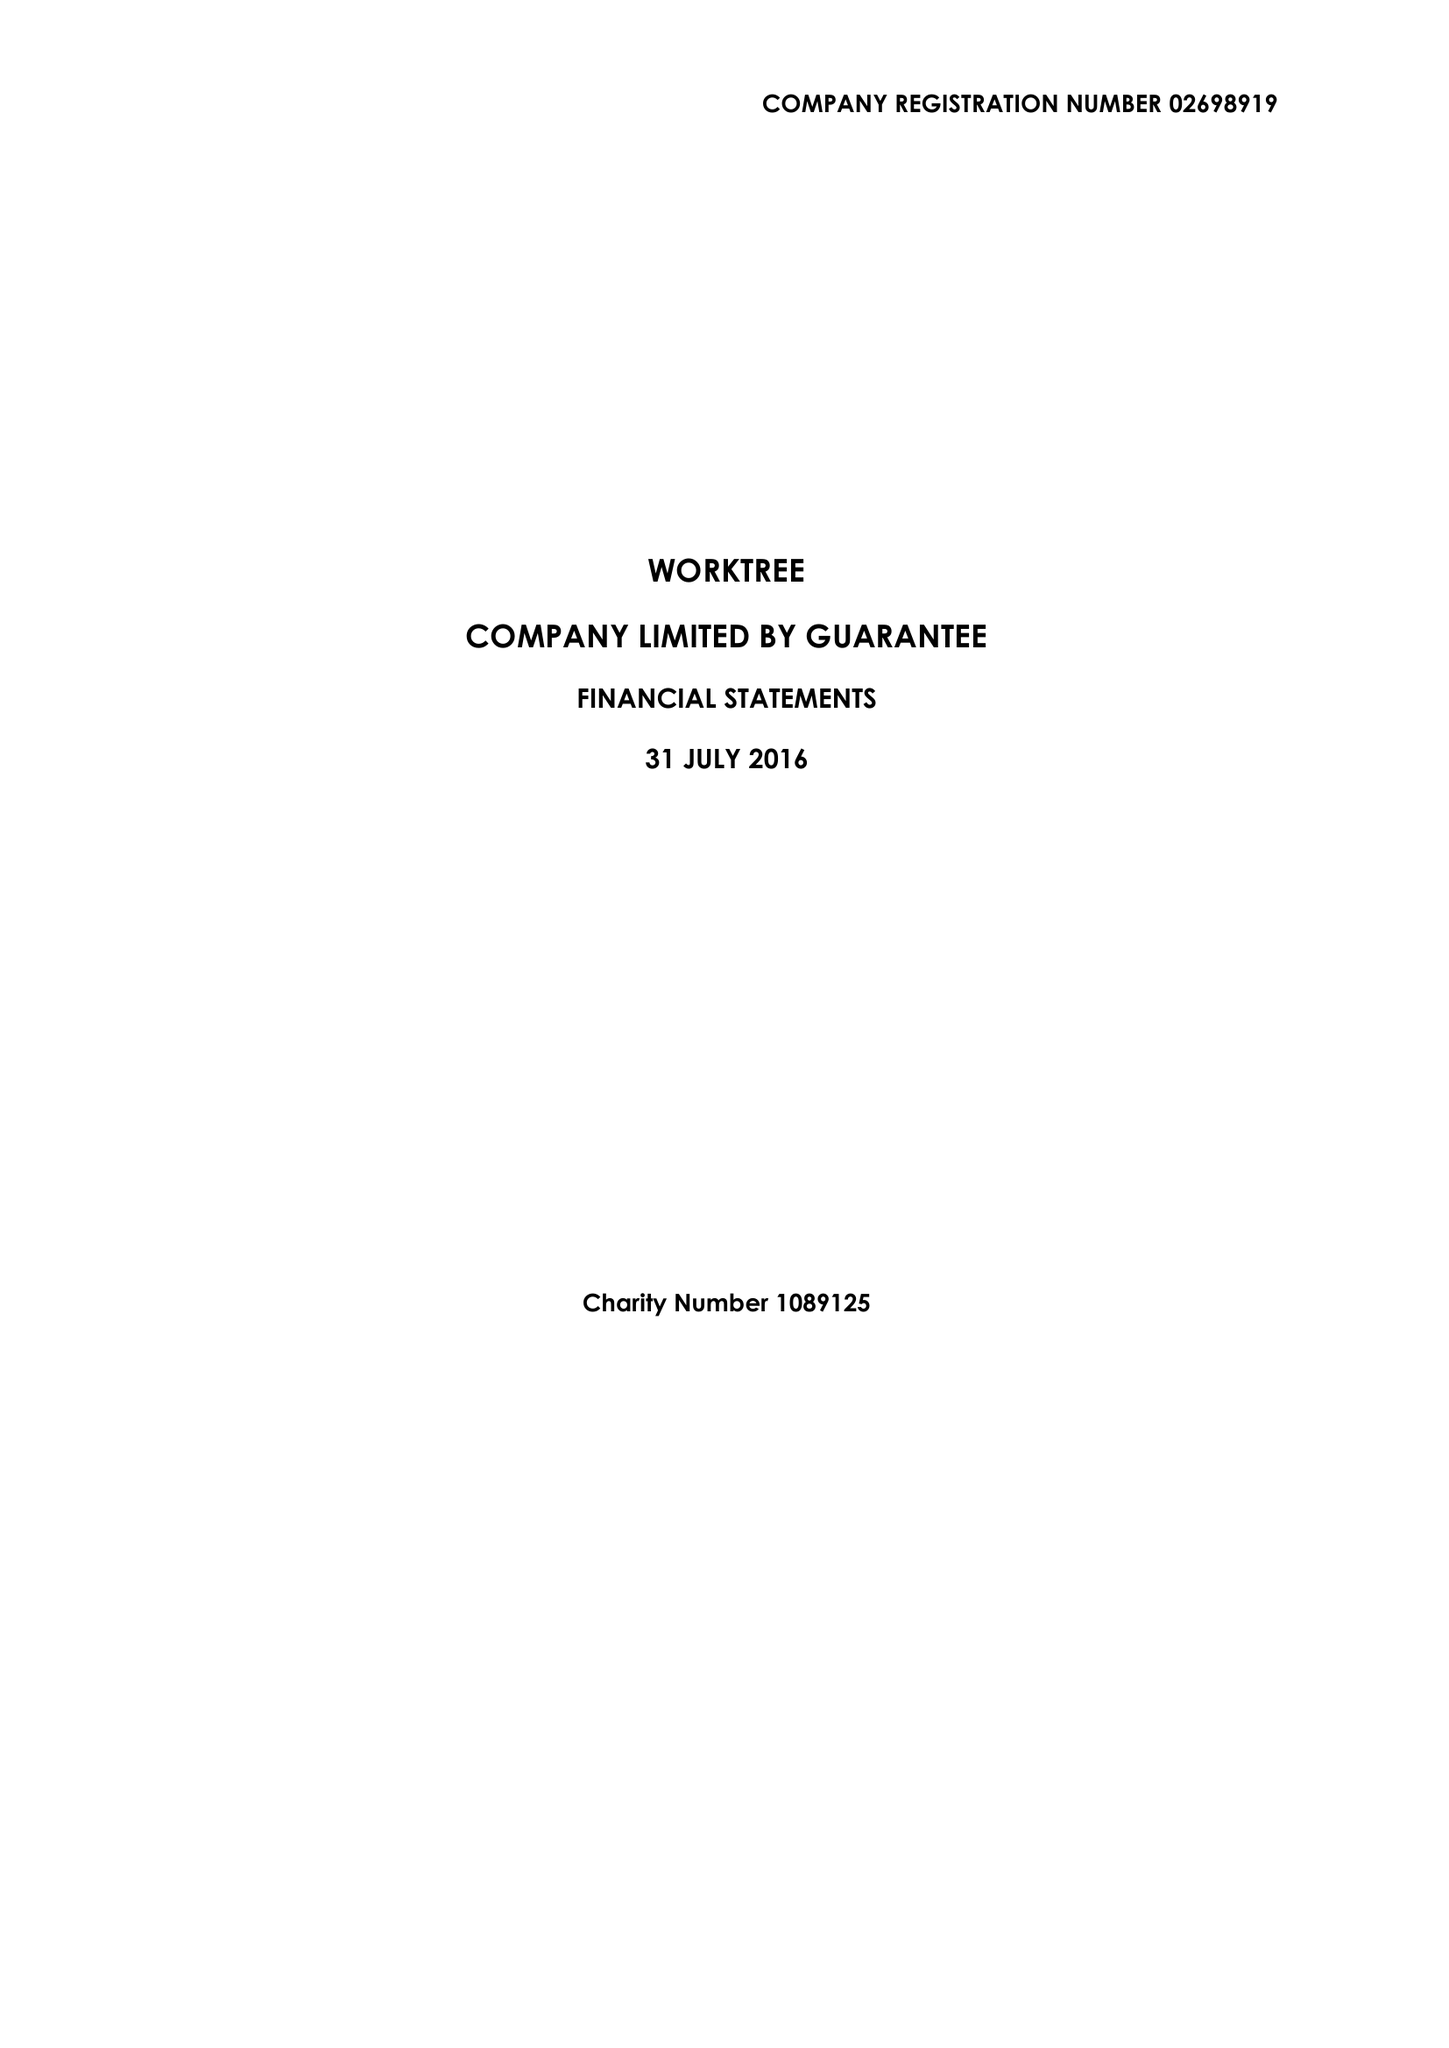What is the value for the address__street_line?
Answer the question using a single word or phrase. 28-29 CLARKE ROAD 